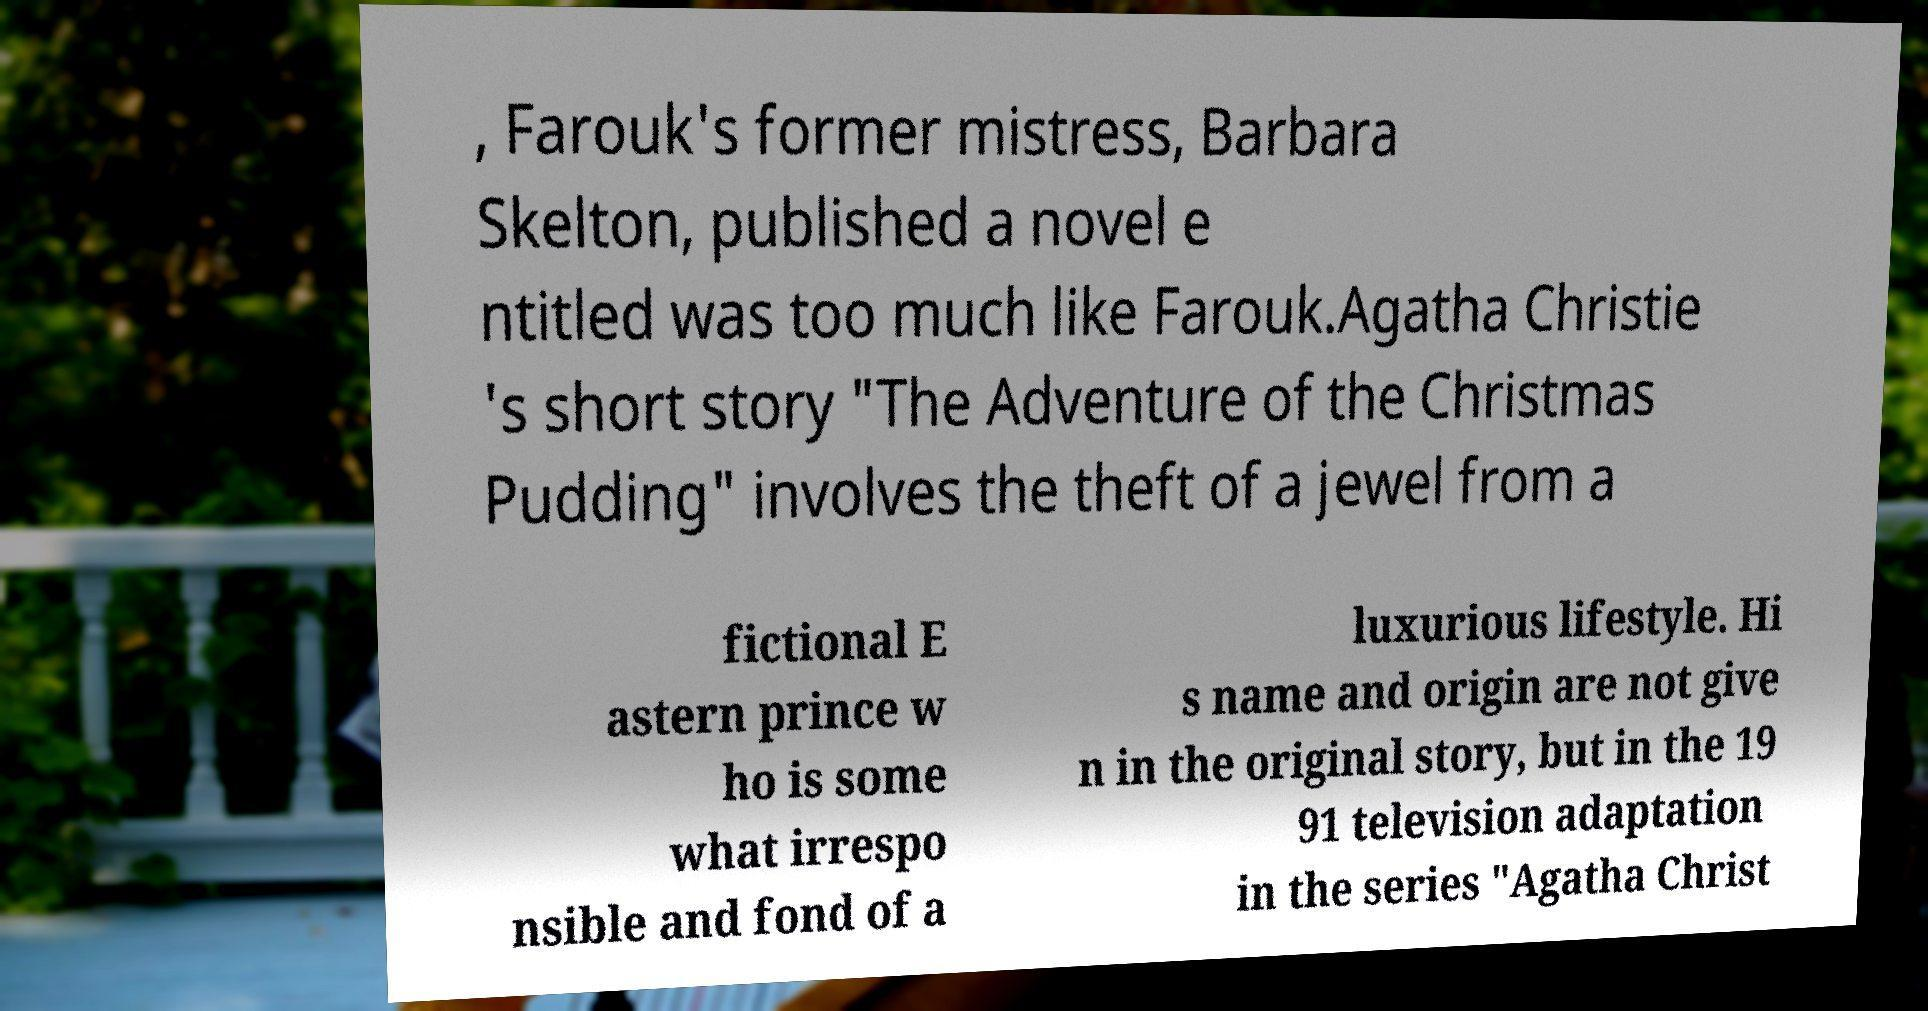For documentation purposes, I need the text within this image transcribed. Could you provide that? , Farouk's former mistress, Barbara Skelton, published a novel e ntitled was too much like Farouk.Agatha Christie 's short story "The Adventure of the Christmas Pudding" involves the theft of a jewel from a fictional E astern prince w ho is some what irrespo nsible and fond of a luxurious lifestyle. Hi s name and origin are not give n in the original story, but in the 19 91 television adaptation in the series "Agatha Christ 